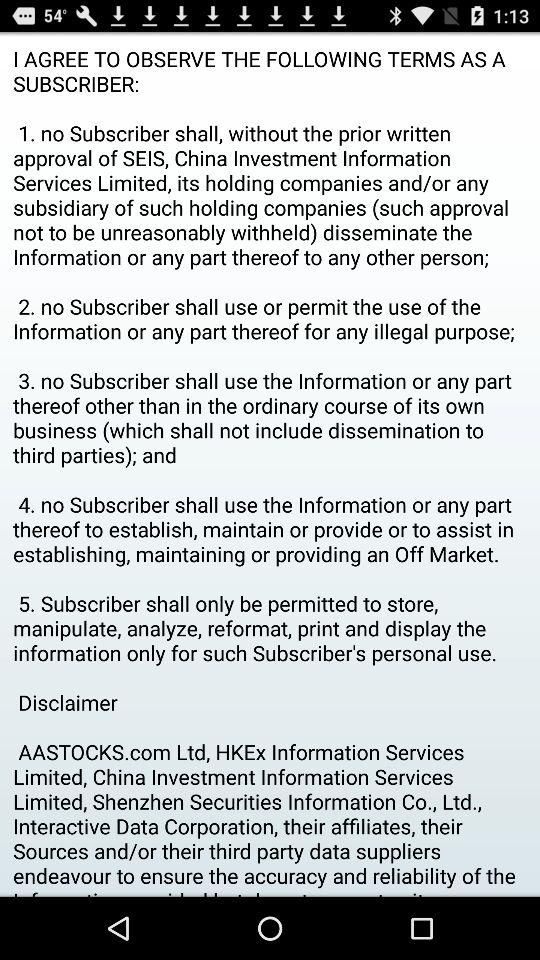How many terms are there in the subscriber agreement?
Answer the question using a single word or phrase. 5 